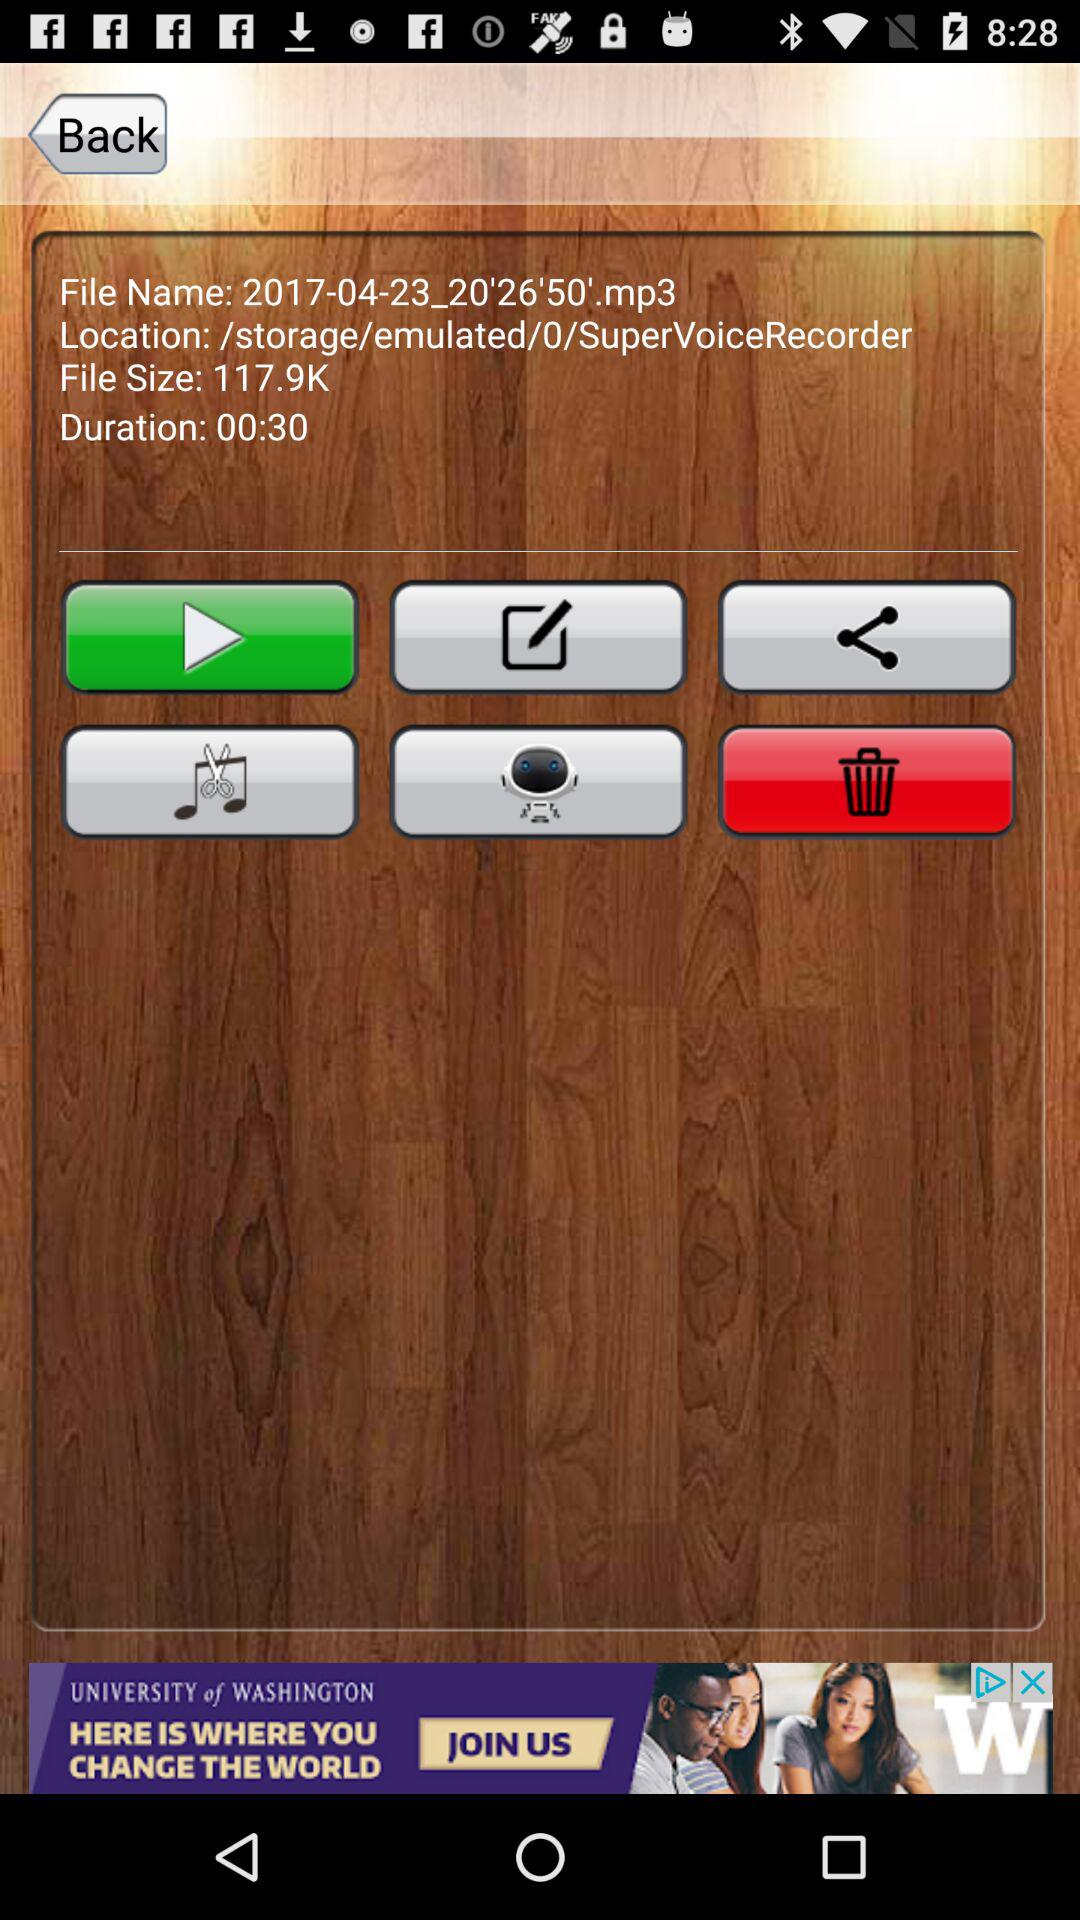What is the storage location of the file? The storage location of the file is /storage/emulated/0/SuperVoiceRecorder. 